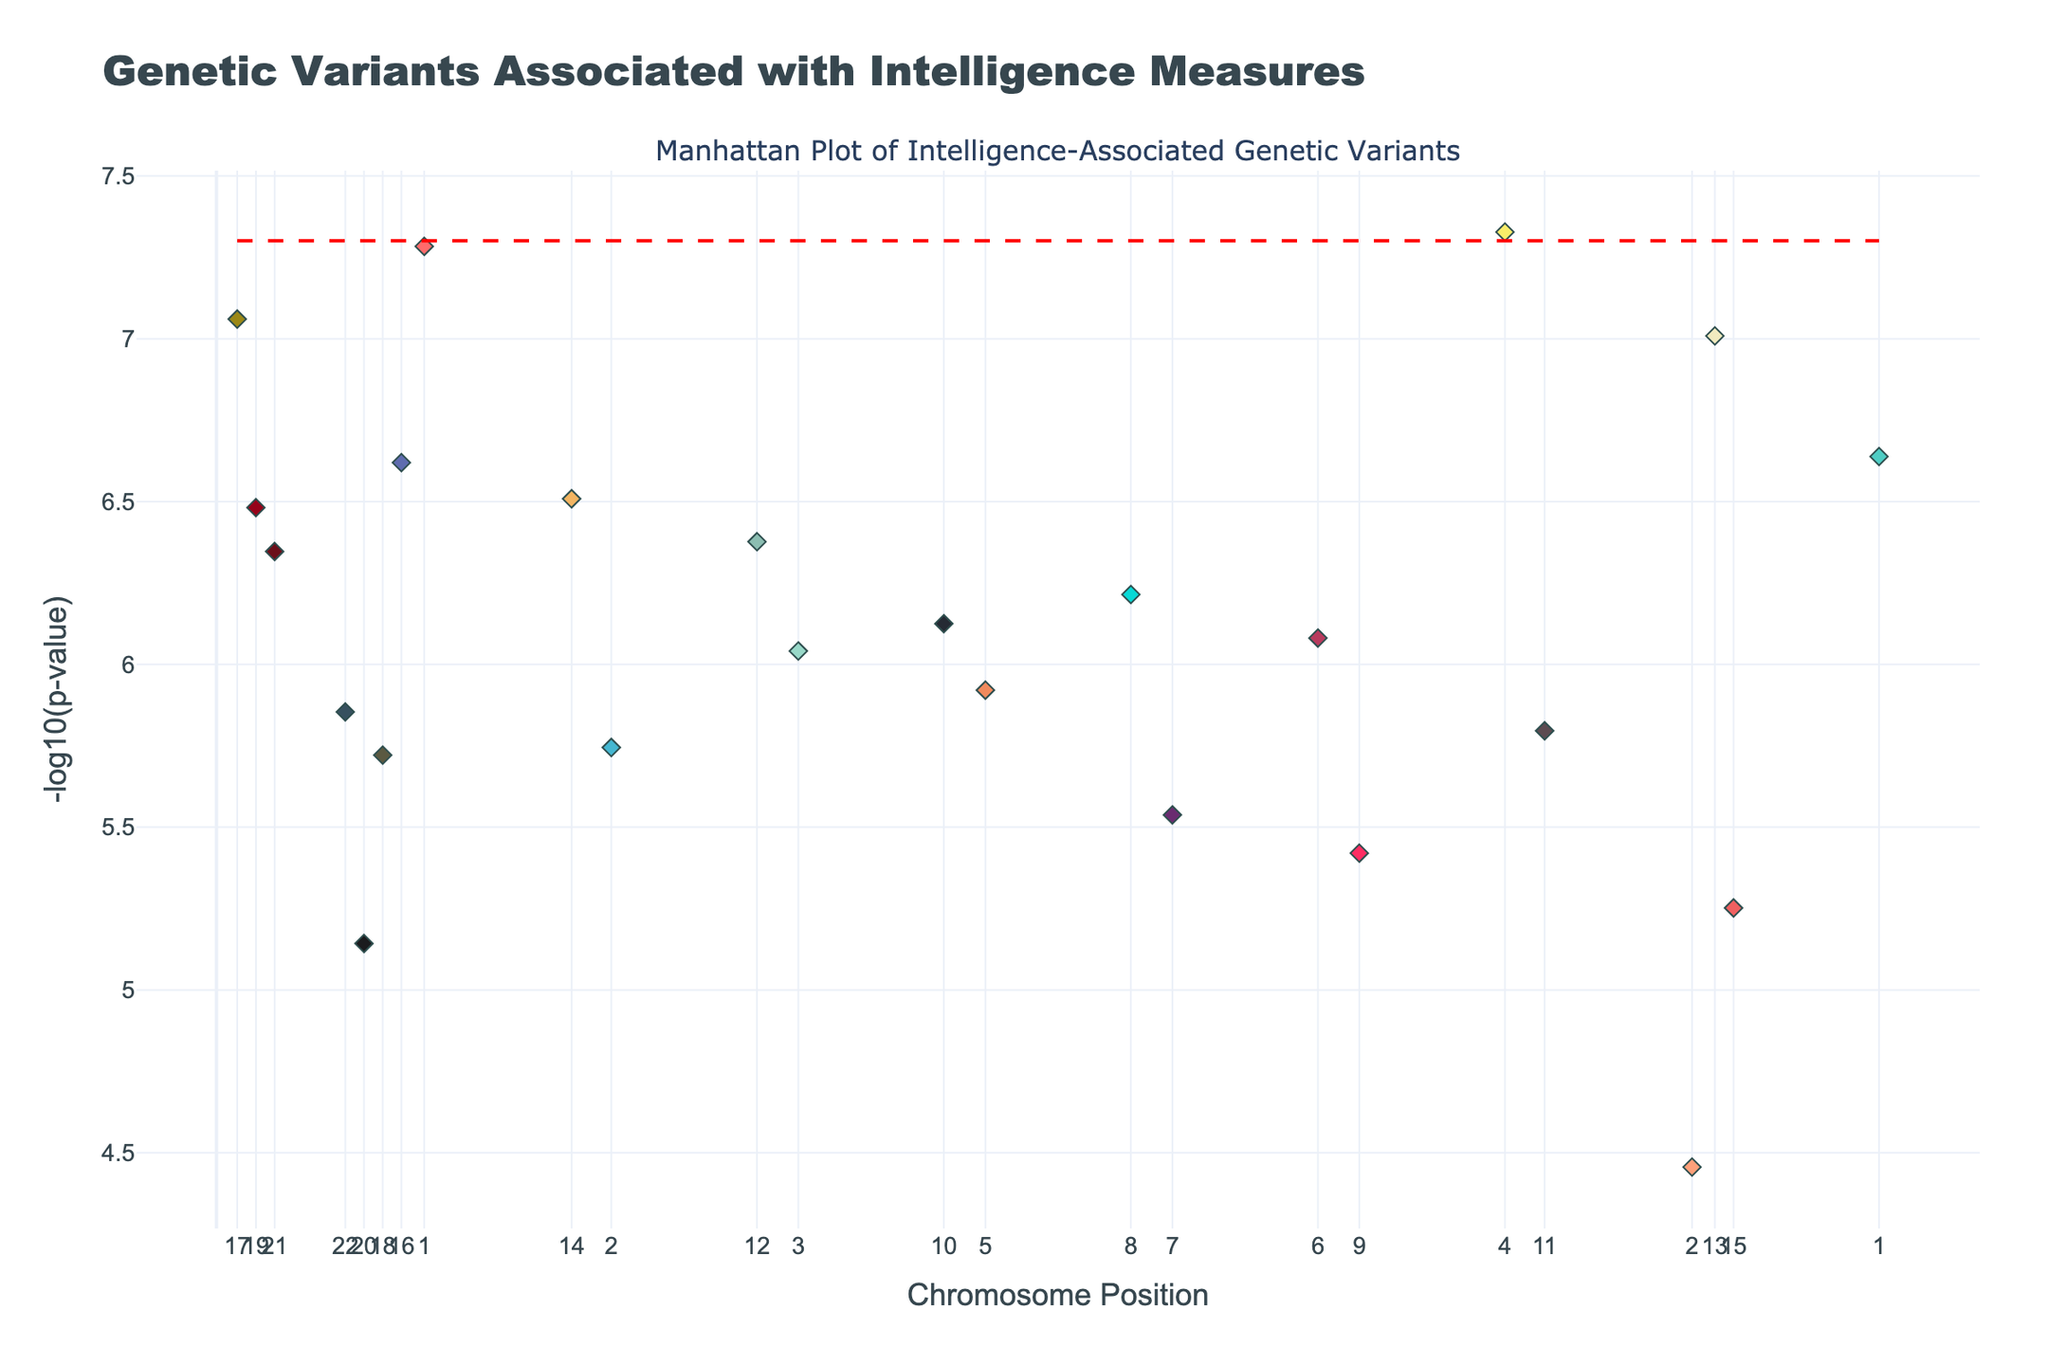How many intelligence measures are represented in the plot? Count each unique intelligence measure listed in the legend of the plot.
Answer: 22 What is the title of the Manhattan Plot? The title is displayed at the top center of the figure.
Answer: Genetic Variants Associated with Intelligence Measures Which intelligence measure has the highest negative log p-value, and what is its value? Find the data point with the highest y-value, check the color, and match it with the intelligence measure in the legend or hover information.
Answer: Working Memory, ~7.28 Between Cognitive Flexibility and Logical Reasoning, which has a lower p-value, and what are their values? Compare the heights of the data points for Cognitive Flexibility and Logical Reasoning; higher y-values indicate lower p-values.
Answer: Cognitive Flexibility (~3.51e-7), Logical Reasoning (~2.4e-7) What is the chromosomal position range covered in the plot? Check the x-axis for the minimum and maximum position values.
Answer: 123456 to 8901234 How many genetic variants have a p-value less than 5e-8? Identify the data points above the red significance line on the plot and count them.
Answer: 3 Which chromosome has the most data points represented in the plot? Check the x-ticks and count the data points corresponding to each chromosome.
Answer: Chromosome 1 Compare the negative log p-values of rs429358 and rs1800497. Which one is higher, and by how much? Locate the data points for rs429358 and rs1800497, compare their y-values, and calculate the difference.
Answer: rs429358 (~7.3) > rs1800497 (~6.038), Difference: ~1.262 What is the approximate negative log p-value threshold indicated by the red dashed line in the plot? Identify the y-value of the red dashed line from the plot.
Answer: 7.30 How many data points are associated with Executive Function, and what are their negative log p-values? Find the points colored for Executive Function and list their negative log p-values.
Answer: 2, (6.92, 5.72) 